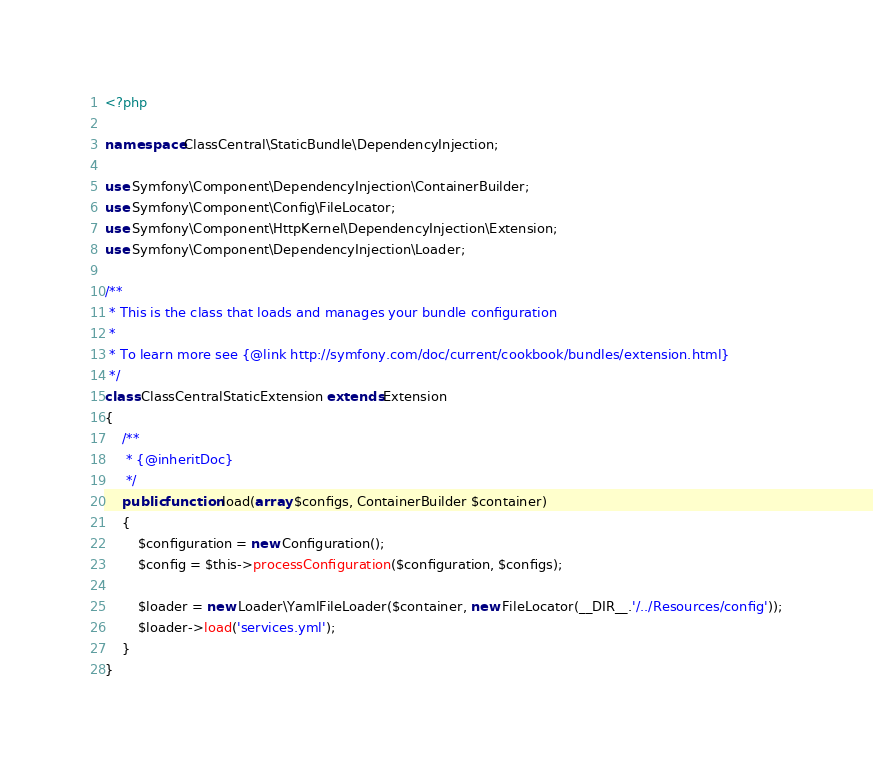<code> <loc_0><loc_0><loc_500><loc_500><_PHP_><?php

namespace ClassCentral\StaticBundle\DependencyInjection;

use Symfony\Component\DependencyInjection\ContainerBuilder;
use Symfony\Component\Config\FileLocator;
use Symfony\Component\HttpKernel\DependencyInjection\Extension;
use Symfony\Component\DependencyInjection\Loader;

/**
 * This is the class that loads and manages your bundle configuration
 *
 * To learn more see {@link http://symfony.com/doc/current/cookbook/bundles/extension.html}
 */
class ClassCentralStaticExtension extends Extension
{
    /**
     * {@inheritDoc}
     */
    public function load(array $configs, ContainerBuilder $container)
    {
        $configuration = new Configuration();
        $config = $this->processConfiguration($configuration, $configs);

        $loader = new Loader\YamlFileLoader($container, new FileLocator(__DIR__.'/../Resources/config'));
        $loader->load('services.yml');
    }
}
</code> 